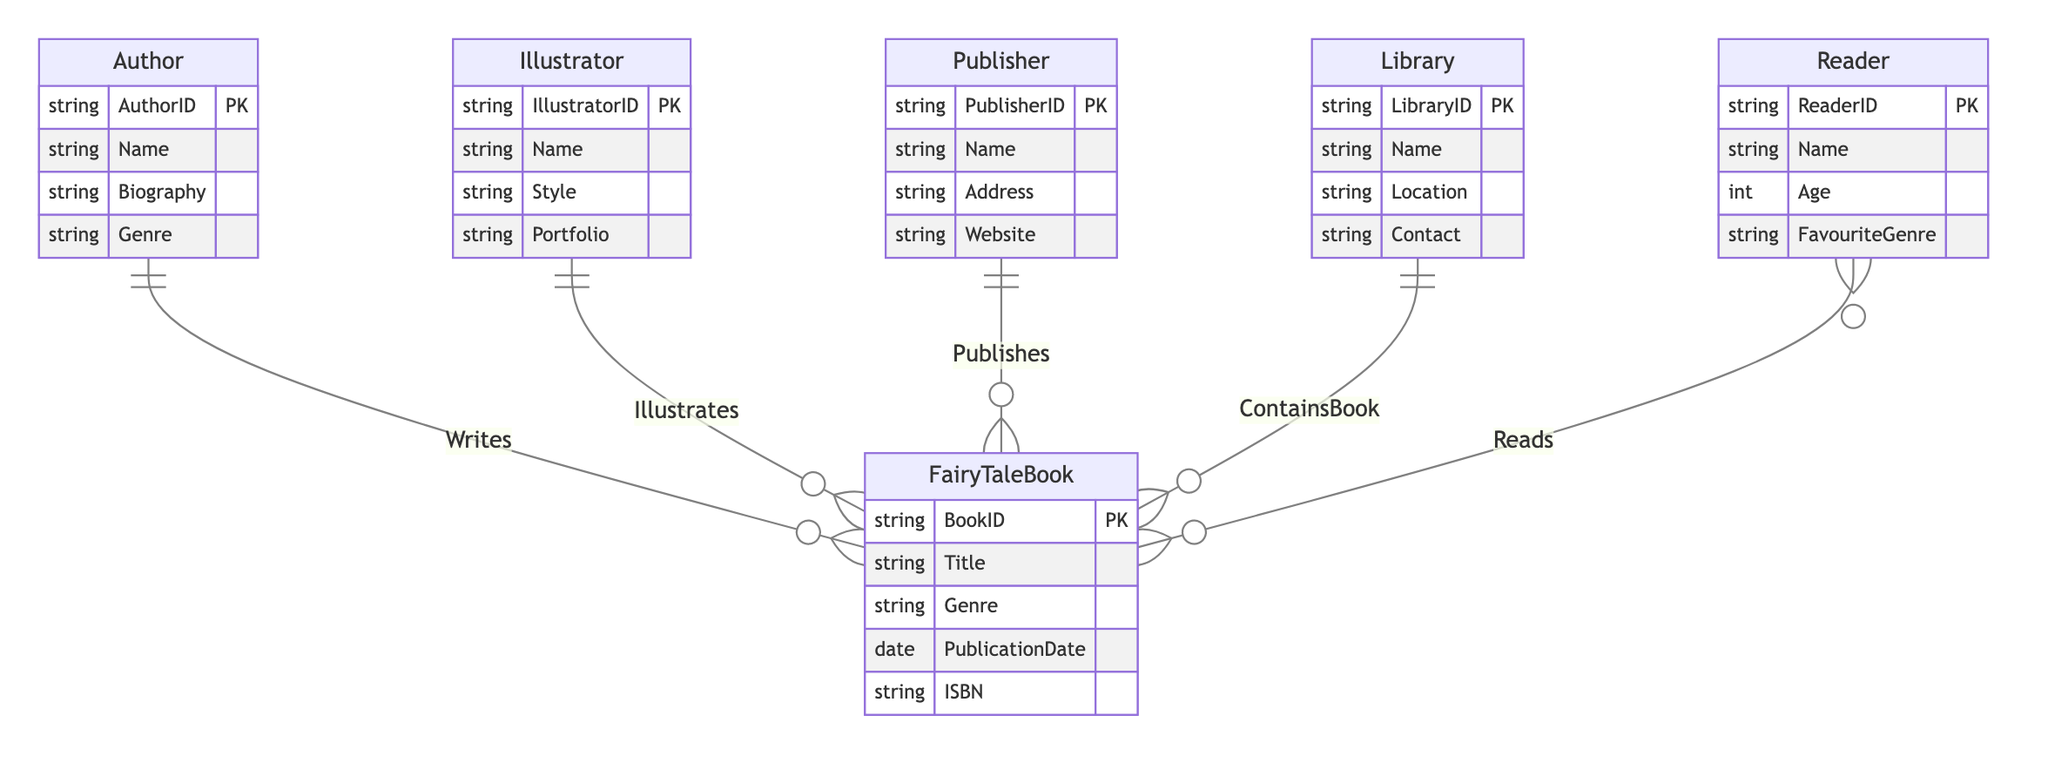What entities are involved in the creation of a Fairy Tale Book? The diagram shows three entities involved in the creation of a Fairy Tale Book: Author, Illustrator, and Publisher. Each of these entities has a specific relationship with the Fairy Tale Book.
Answer: Author, Illustrator, Publisher How many attributes does the Publisher entity have? The Publisher entity has four attributes: PublisherID, Name, Address, and Website. This can be counted directly from the diagram.
Answer: 4 What is the relationship between Reader and Fairy Tale Book? The Reader entity is related to Fairy Tale Book through the Reads relationship, which is many-to-many, indicating that many readers can read many different fairy tale books.
Answer: Reads Which entity is responsible for adding books to the library? The Library entity contains the ContainsBook relationship, indicating that the library is responsible for containing or organizing specific fairy tale books.
Answer: Library What type of relationship exists between Illustrator and Fairy Tale Book? The relationship between Illustrator and Fairy Tale Book is one-to-many, meaning one illustrator can illustrate multiple fairy tale books. This is indicated by the "Illustrates" relationship in the diagram.
Answer: one-to-many How many entities are shown in the diagram? The diagram has a total of five entities: Author, Illustrator, Publisher, Fairy Tale Book, Library, and Reader. Counting them results in six entities.
Answer: 6 Which entity can a Reader have a relationship with? The Reader can have a relationship with the Fairy Tale Book entity through the Reads relationship. This shows that readers engage with the fairy tale books.
Answer: Fairy Tale Book What is the primary key for the Author entity? The primary key for the Author entity is AuthorID, which uniquely identifies each author in the database or diagram context.
Answer: AuthorID What type of information does the Biography attribute in the Author entity represent? The Biography attribute in the Author entity represents descriptive information about the author's life, experiences, and background, providing more context about the author.
Answer: Descriptive information 